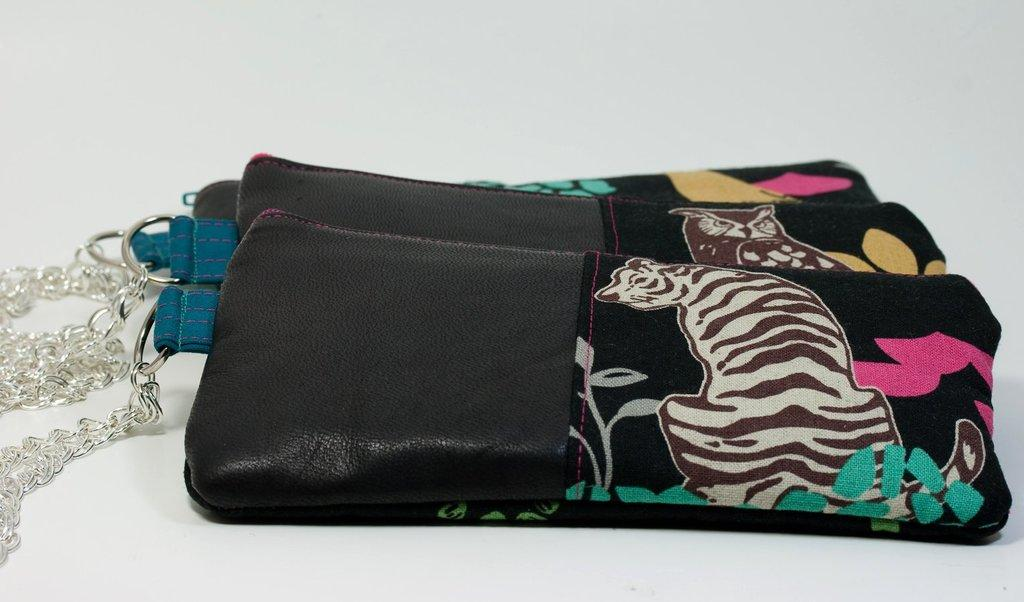What objects are visible in the image? There are wallets in the image. Where are the wallets located? The wallets are placed on a table. What type of riddle can be solved using the wallets in the image? There is no riddle present in the image, nor are the wallets used for solving any riddles. 